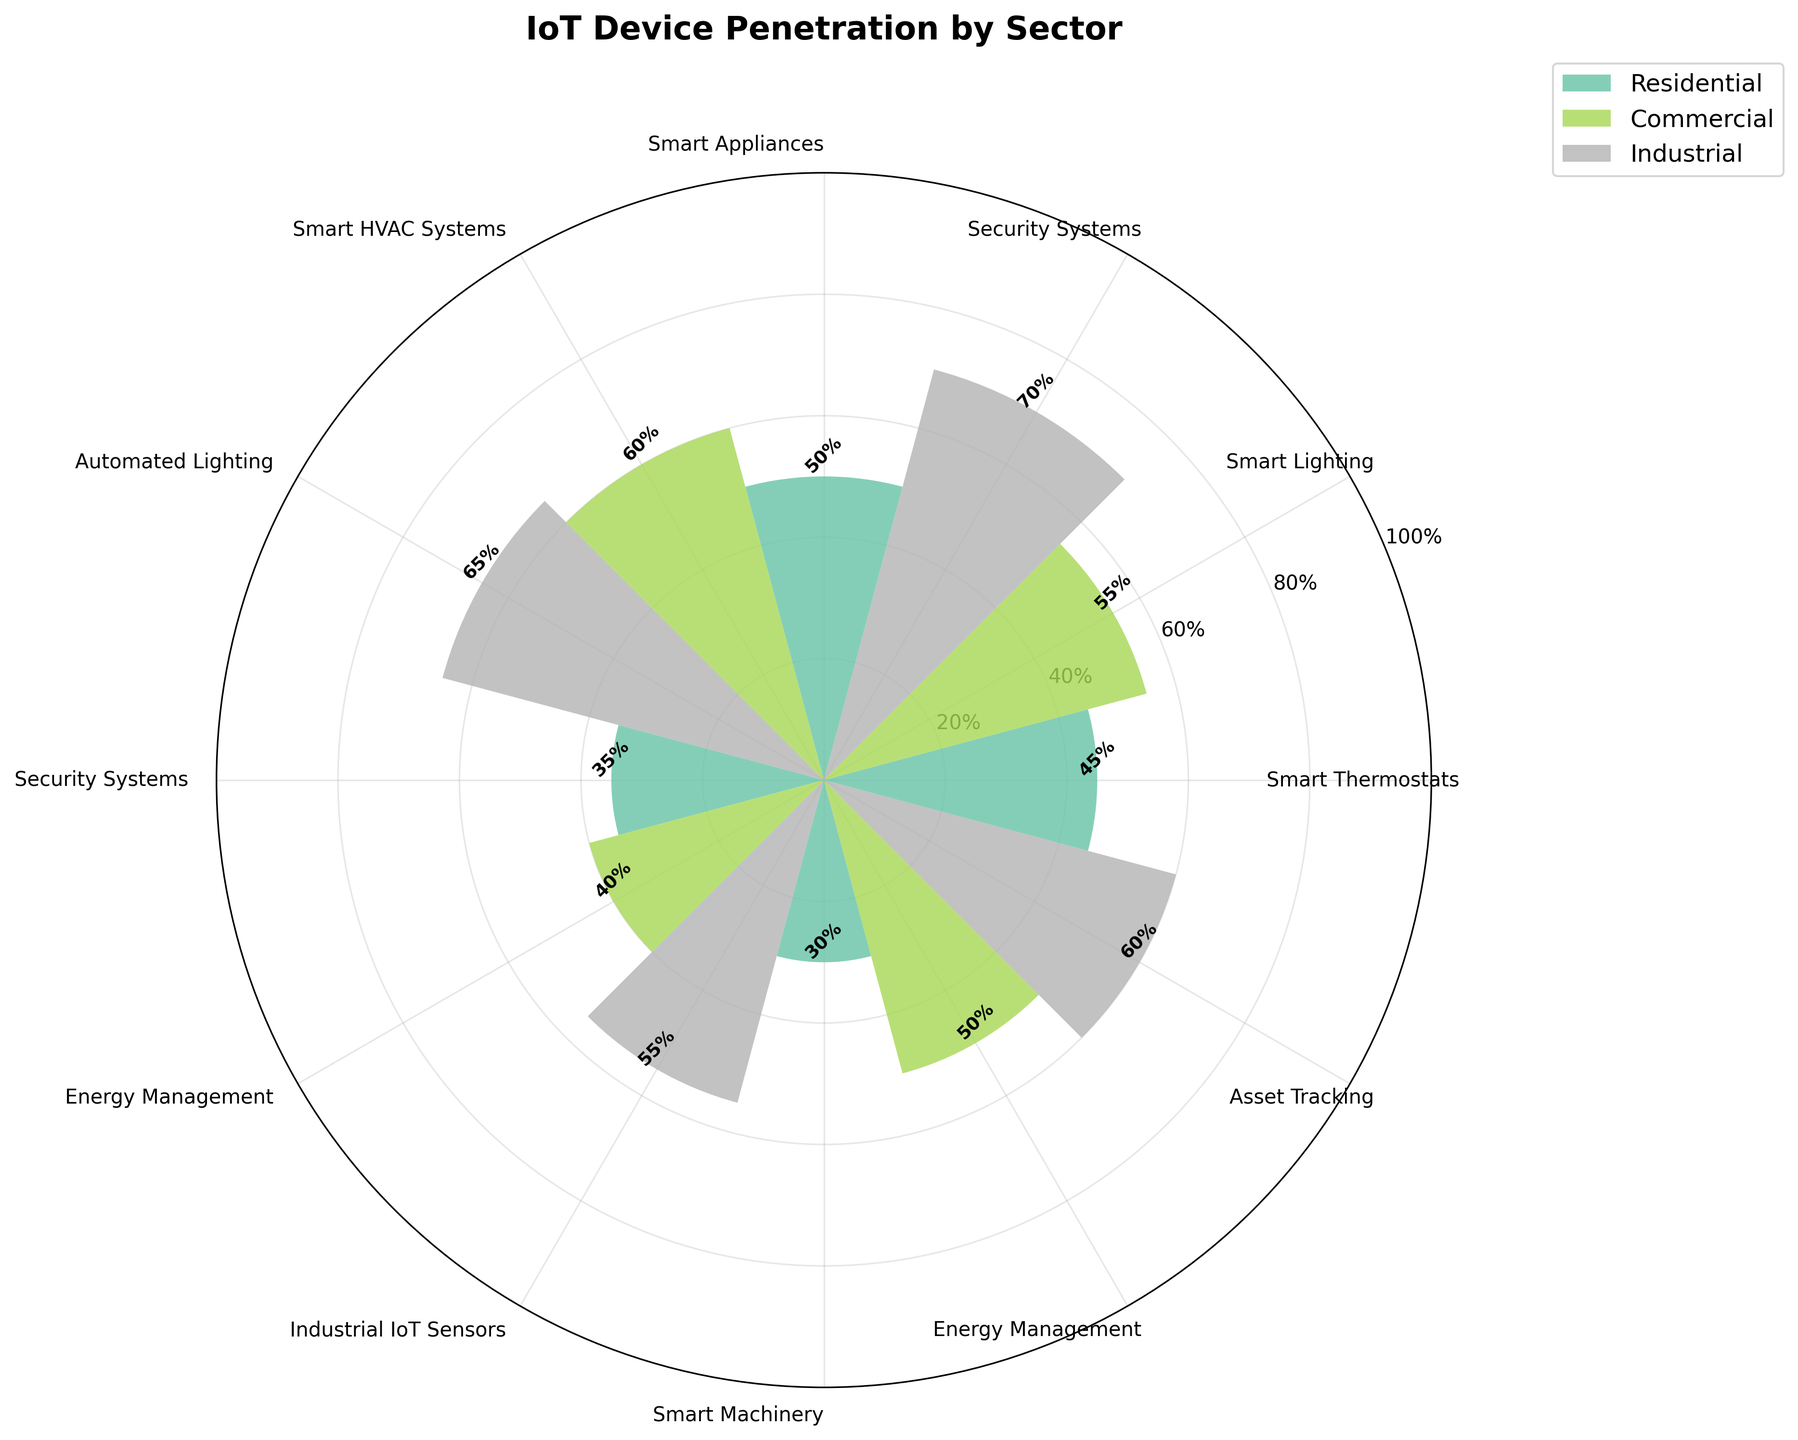What is the title of the plot? The title is prominently displayed at the top of the chart.
Answer: IoT Device Penetration by Sector How many sectors are represented in the plot? By counting the different colors used in the chart and consulting the legend, we can see there are three sectors.
Answer: Three Which sector has the highest penetration of its IoT device category and what is the percentage? Reviewing the bars, the Industrial sector with Industrial IoT Sensors has the highest percentage at 70%.
Answer: Industrial, 70% What is the percentage penetration of Smart Thermostats in the Residential sector? Look at the specific bar labeled Smart Thermostats in the Residential sector and read the percentage.
Answer: 45% Which category has the lowest penetration in the Residential sector? Look at the smallest bar in the Residential sector to find Smart Appliances.
Answer: Smart Appliances Compare the penetration of Security Systems in both the Residential and Commercial sectors. Which is higher and by how much? Security Systems in the Residential sector is at 35%, and in the Commercial sector is at 40%. The difference is 5%.
Answer: Commercial by 5% What is the average penetration of IoT devices in the Commercial sector? Add the percentages of all categories in the Commercial sector (55 + 60 + 40 + 50) and divide by 4 to find the average.
Answer: 51.25% Among the Industrial sector, which category has the second highest penetration? Identify the highest percentage first (70% for Industrial IoT Sensors), then find the next highest (65% for Smart Machinery).
Answer: Smart Machinery Compare the average IoT penetration between Residential and Industrial sectors. Which sector has a higher average and by how much? Calculate the average for Residential (45+50+35+30=160, 160/4 = 40%) and for Industrial (70+65+55+60=250, 250/4 = 62.5%), then find the difference.
Answer: Industrial by 22.5% By how much does the penetration of Automated Lighting in the Commercial sector exceed that of Energy Management in the same sector? Automated Lighting is at 60%, and Energy Management is at 50%. The difference is 10%.
Answer: 10% 